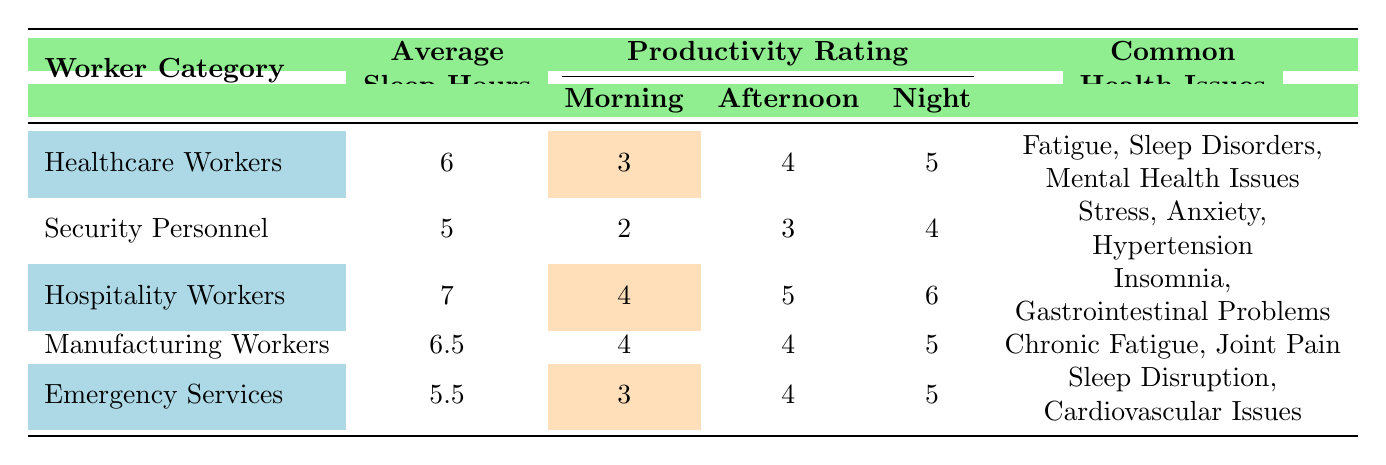What is the average number of sleep hours for Security Personnel? The average sleep hours for Security Personnel is given directly in the table under the "Average Sleep Hours" column. It states that Security Personnel have an average of 5 sleep hours.
Answer: 5 What is the productivity rating for Healthcare Workers during the Afternoon? The productivity rating for Healthcare Workers during the Afternoon is specified in the table in the "Productivity Rating" section under "Afternoon." It shows a rating of 4.
Answer: 4 Which worker category has the highest average sleep hours? The table lists the average sleep hours for each worker category. Upon reviewing, Hospitality Workers have the highest value of 7 average sleep hours.
Answer: Hospitality Workers True or False: Manufacturing Workers reported lower average sleep hours than Healthcare Workers. The average sleep hours for Manufacturing Workers is 6.5, while for Healthcare Workers it is 6. Since 6.5 is greater than 6, the statement is false.
Answer: False What is the difference in average sleep hours between Hospitality Workers and Security Personnel? The average sleep hours for Hospitality Workers is 7 and for Security Personnel, it is 5. The difference is calculated as 7 - 5 = 2.
Answer: 2 Which worker category has the lowest productivity rating during the Morning? The productivity ratings for the Morning are listed for each category. Security Personnel has the lowest rating of 2 in this column.
Answer: Security Personnel What is the common health issue facing Emergency Services workers? The common health issues for Emergency Services workers are listed under "Common Health Issues." It includes "Sleep Disruption" and "Cardiovascular Issues."
Answer: Sleep Disruption, Cardiovascular Issues If you sum the average sleep hours of Healthcare and Emergency Services workers, what is the total? The average sleep hours for Healthcare Workers is 6 and for Emergency Services, it is 5. Summing these values gives 6 + 5 = 11.
Answer: 11 How does the productivity rating of Hospitality Workers at Night compare to that of Security Personnel? Hospitality Workers have a Night productivity rating of 6, while Security Personnel have a Night productivity rating of 4. Comparing these values shows that Hospitality Workers have a higher rating by 2 points (6 - 4 = 2).
Answer: Hospitality Workers are higher by 2 points 